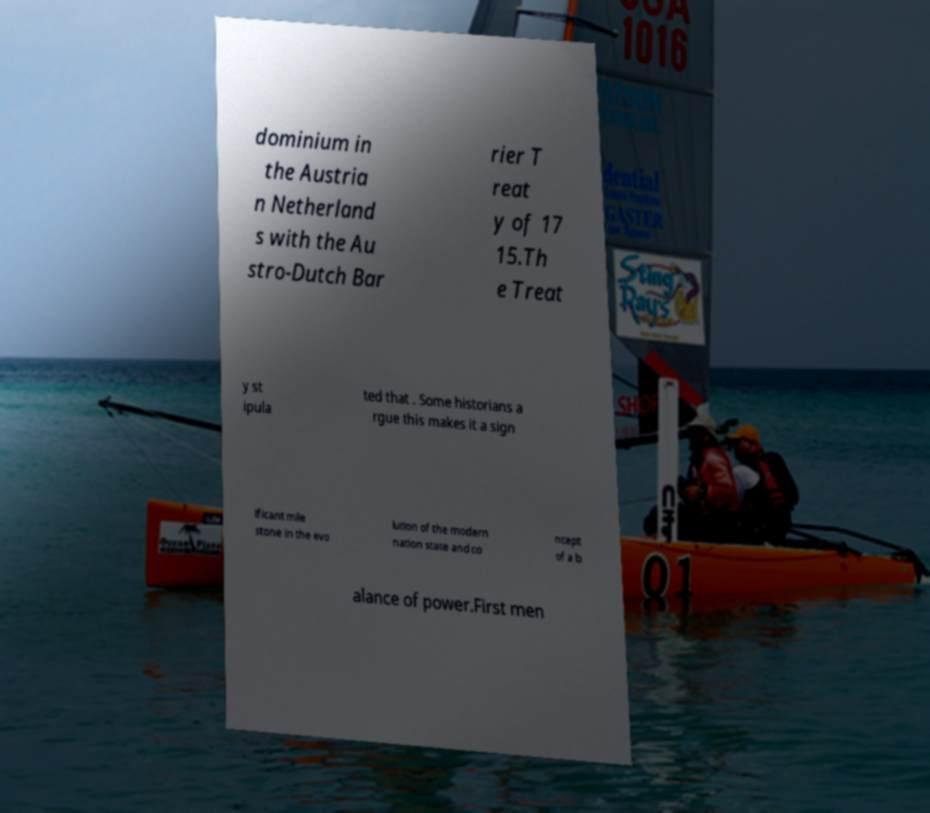Can you accurately transcribe the text from the provided image for me? dominium in the Austria n Netherland s with the Au stro-Dutch Bar rier T reat y of 17 15.Th e Treat y st ipula ted that . Some historians a rgue this makes it a sign ificant mile stone in the evo lution of the modern nation state and co ncept of a b alance of power.First men 